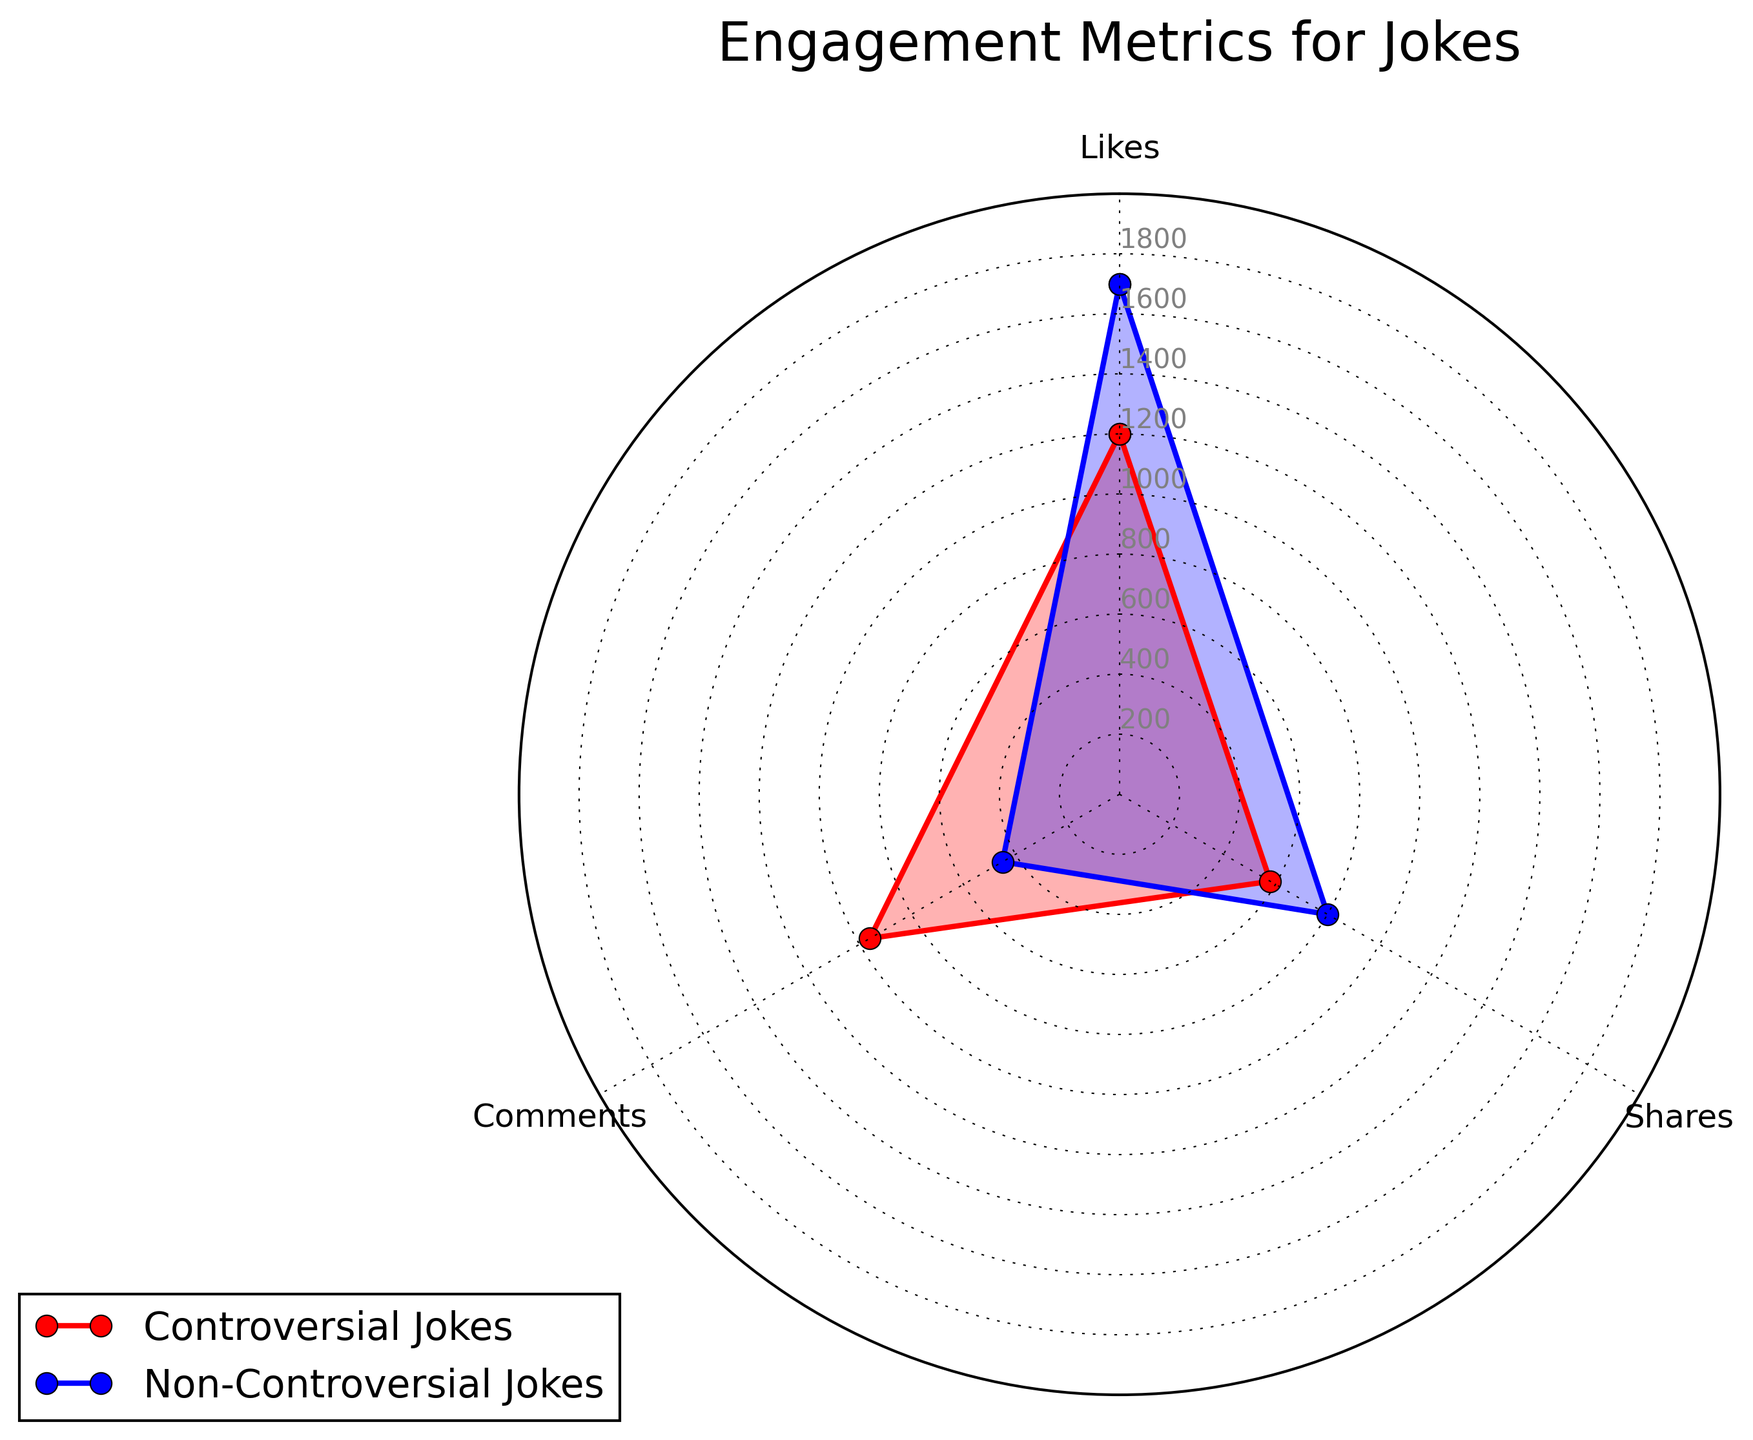What are the total Likes for both Controversial and Non-Controversial Jokes combined? To find the total likes for both types of jokes, add the likes for Controversial Jokes (1200) and Non-Controversial Jokes (1700). So, the total is 1200 + 1700 = 2900.
Answer: 2900 Which engagement metric has the largest difference between Controversial and Non-Controversial Jokes? To find the largest difference, calculate the differences for each metric: Likes (1700-1200 = 500), Shares (800-580 = 220), Comments (960-450 = 510). The largest difference is for Comments, which is 510.
Answer: Comments Are Controversial Jokes or Non-Controversial Jokes more consistently high across all metrics? Compare each month's engagement metrics: Non-Controversial Jokes have higher or equal values in all three metrics (Likes, Shares, Comments) compared to Controversial Jokes: Likes (1700 > 1200), Shares (800 > 580), Comments (960 > 450). Non-Controversial Jokes are more consistently high.
Answer: Non-Controversial Jokes Which engagement metric do Controversial Jokes perform better in compared to Non-Controversial Jokes? Compare each engagement metric: Controversial Jokes perform better in Comments (960) compared to Non-Controversial Jokes (450); for Likes and Shares, Non-Controversial Jokes perform better.
Answer: Comments What is the average number of Shares for both Controversial and Non-Controversial Jokes? To find the average number of Shares, add the Shares for both types of jokes: (580 for Controversial + 800 for Non-Controversial) and divide by 2. So, (580 + 800) / 2 = 690.
Answer: 690 By how much do Non-Controversial Jokes exceed Controversial Jokes in Likes and Shares combined? First, calculate the combined Likes and Shares for each: Non-Controversial Jokes (1700 Likes + 800 Shares = 2500) and Controversial Jokes (1200 Likes + 580 Shares = 1780). The difference is 2500 - 1780 = 720.
Answer: 720 What is the ratio of Comments on Controversial Jokes to Comments on Non-Controversial Jokes? To find the ratio, divide the number of Comments on Controversial Jokes (960) by the number of Comments on Non-Controversial Jokes (450). So, 960 / 450 = 2.13.
Answer: 2.13 